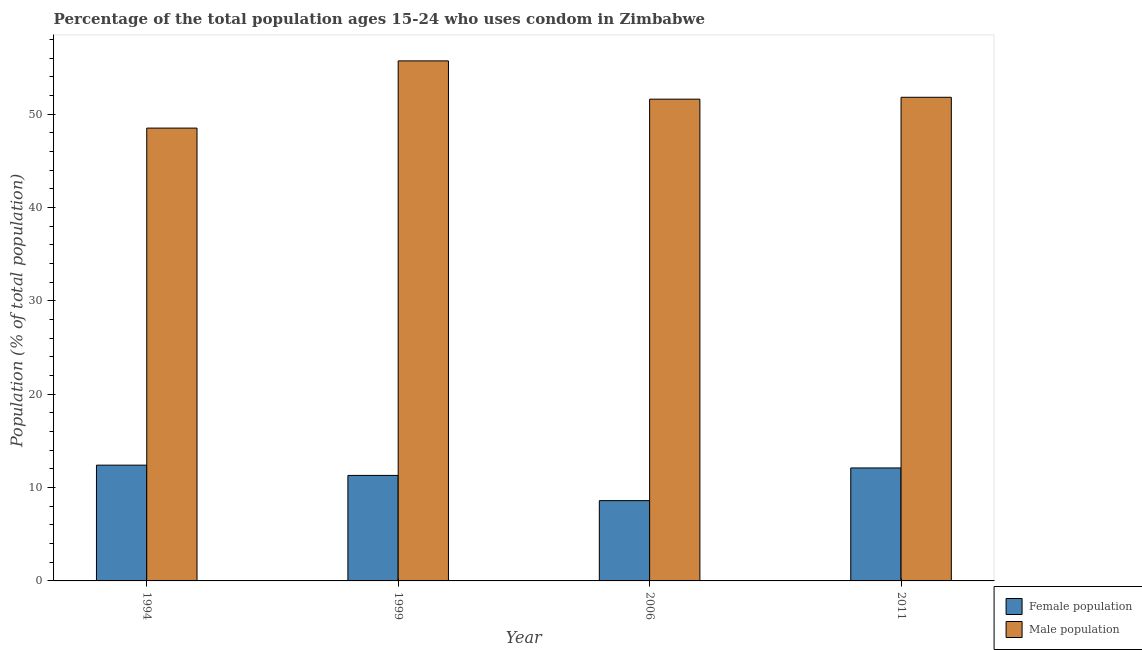How many different coloured bars are there?
Make the answer very short. 2. Are the number of bars per tick equal to the number of legend labels?
Keep it short and to the point. Yes. Are the number of bars on each tick of the X-axis equal?
Make the answer very short. Yes. How many bars are there on the 1st tick from the left?
Your answer should be compact. 2. What is the male population in 1994?
Your answer should be compact. 48.5. In which year was the female population maximum?
Offer a terse response. 1994. In which year was the female population minimum?
Offer a terse response. 2006. What is the total male population in the graph?
Your answer should be very brief. 207.6. What is the difference between the male population in 1994 and that in 1999?
Ensure brevity in your answer.  -7.2. What is the difference between the male population in 2011 and the female population in 1999?
Offer a terse response. -3.9. What is the average female population per year?
Your answer should be very brief. 11.1. In the year 2011, what is the difference between the male population and female population?
Ensure brevity in your answer.  0. What is the ratio of the female population in 1999 to that in 2011?
Make the answer very short. 0.93. Is the female population in 2006 less than that in 2011?
Your response must be concise. Yes. What is the difference between the highest and the second highest male population?
Your answer should be compact. 3.9. What is the difference between the highest and the lowest male population?
Offer a very short reply. 7.2. In how many years, is the male population greater than the average male population taken over all years?
Keep it short and to the point. 1. Is the sum of the male population in 1999 and 2006 greater than the maximum female population across all years?
Offer a terse response. Yes. What does the 2nd bar from the left in 2011 represents?
Provide a succinct answer. Male population. What does the 1st bar from the right in 2011 represents?
Keep it short and to the point. Male population. How many bars are there?
Give a very brief answer. 8. Are all the bars in the graph horizontal?
Provide a succinct answer. No. Does the graph contain grids?
Keep it short and to the point. No. How many legend labels are there?
Offer a terse response. 2. What is the title of the graph?
Give a very brief answer. Percentage of the total population ages 15-24 who uses condom in Zimbabwe. What is the label or title of the Y-axis?
Offer a very short reply. Population (% of total population) . What is the Population (% of total population)  of Male population in 1994?
Keep it short and to the point. 48.5. What is the Population (% of total population)  in Female population in 1999?
Your answer should be compact. 11.3. What is the Population (% of total population)  in Male population in 1999?
Your answer should be compact. 55.7. What is the Population (% of total population)  in Female population in 2006?
Make the answer very short. 8.6. What is the Population (% of total population)  of Male population in 2006?
Ensure brevity in your answer.  51.6. What is the Population (% of total population)  in Female population in 2011?
Your answer should be compact. 12.1. What is the Population (% of total population)  in Male population in 2011?
Provide a succinct answer. 51.8. Across all years, what is the maximum Population (% of total population)  in Male population?
Keep it short and to the point. 55.7. Across all years, what is the minimum Population (% of total population)  in Female population?
Give a very brief answer. 8.6. Across all years, what is the minimum Population (% of total population)  in Male population?
Give a very brief answer. 48.5. What is the total Population (% of total population)  in Female population in the graph?
Make the answer very short. 44.4. What is the total Population (% of total population)  of Male population in the graph?
Ensure brevity in your answer.  207.6. What is the difference between the Population (% of total population)  of Female population in 1994 and that in 1999?
Keep it short and to the point. 1.1. What is the difference between the Population (% of total population)  of Female population in 1994 and that in 2006?
Offer a very short reply. 3.8. What is the difference between the Population (% of total population)  of Female population in 1994 and that in 2011?
Give a very brief answer. 0.3. What is the difference between the Population (% of total population)  in Male population in 1994 and that in 2011?
Make the answer very short. -3.3. What is the difference between the Population (% of total population)  in Female population in 1999 and that in 2006?
Your answer should be compact. 2.7. What is the difference between the Population (% of total population)  of Female population in 1999 and that in 2011?
Provide a short and direct response. -0.8. What is the difference between the Population (% of total population)  in Male population in 1999 and that in 2011?
Your answer should be compact. 3.9. What is the difference between the Population (% of total population)  in Female population in 1994 and the Population (% of total population)  in Male population in 1999?
Provide a succinct answer. -43.3. What is the difference between the Population (% of total population)  in Female population in 1994 and the Population (% of total population)  in Male population in 2006?
Ensure brevity in your answer.  -39.2. What is the difference between the Population (% of total population)  in Female population in 1994 and the Population (% of total population)  in Male population in 2011?
Provide a short and direct response. -39.4. What is the difference between the Population (% of total population)  in Female population in 1999 and the Population (% of total population)  in Male population in 2006?
Give a very brief answer. -40.3. What is the difference between the Population (% of total population)  of Female population in 1999 and the Population (% of total population)  of Male population in 2011?
Offer a very short reply. -40.5. What is the difference between the Population (% of total population)  of Female population in 2006 and the Population (% of total population)  of Male population in 2011?
Your answer should be compact. -43.2. What is the average Population (% of total population)  of Male population per year?
Provide a short and direct response. 51.9. In the year 1994, what is the difference between the Population (% of total population)  of Female population and Population (% of total population)  of Male population?
Ensure brevity in your answer.  -36.1. In the year 1999, what is the difference between the Population (% of total population)  of Female population and Population (% of total population)  of Male population?
Your response must be concise. -44.4. In the year 2006, what is the difference between the Population (% of total population)  in Female population and Population (% of total population)  in Male population?
Offer a terse response. -43. In the year 2011, what is the difference between the Population (% of total population)  of Female population and Population (% of total population)  of Male population?
Offer a terse response. -39.7. What is the ratio of the Population (% of total population)  of Female population in 1994 to that in 1999?
Your response must be concise. 1.1. What is the ratio of the Population (% of total population)  in Male population in 1994 to that in 1999?
Offer a terse response. 0.87. What is the ratio of the Population (% of total population)  of Female population in 1994 to that in 2006?
Keep it short and to the point. 1.44. What is the ratio of the Population (% of total population)  of Male population in 1994 to that in 2006?
Keep it short and to the point. 0.94. What is the ratio of the Population (% of total population)  of Female population in 1994 to that in 2011?
Make the answer very short. 1.02. What is the ratio of the Population (% of total population)  in Male population in 1994 to that in 2011?
Keep it short and to the point. 0.94. What is the ratio of the Population (% of total population)  of Female population in 1999 to that in 2006?
Ensure brevity in your answer.  1.31. What is the ratio of the Population (% of total population)  in Male population in 1999 to that in 2006?
Your response must be concise. 1.08. What is the ratio of the Population (% of total population)  in Female population in 1999 to that in 2011?
Provide a short and direct response. 0.93. What is the ratio of the Population (% of total population)  of Male population in 1999 to that in 2011?
Ensure brevity in your answer.  1.08. What is the ratio of the Population (% of total population)  of Female population in 2006 to that in 2011?
Offer a terse response. 0.71. What is the difference between the highest and the second highest Population (% of total population)  of Male population?
Give a very brief answer. 3.9. What is the difference between the highest and the lowest Population (% of total population)  in Male population?
Make the answer very short. 7.2. 